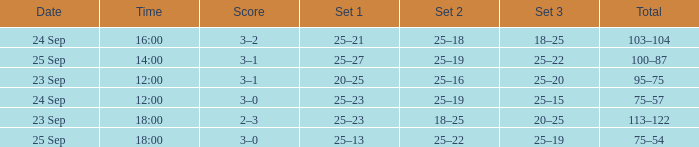What was the score when the time was 14:00? 3–1. 